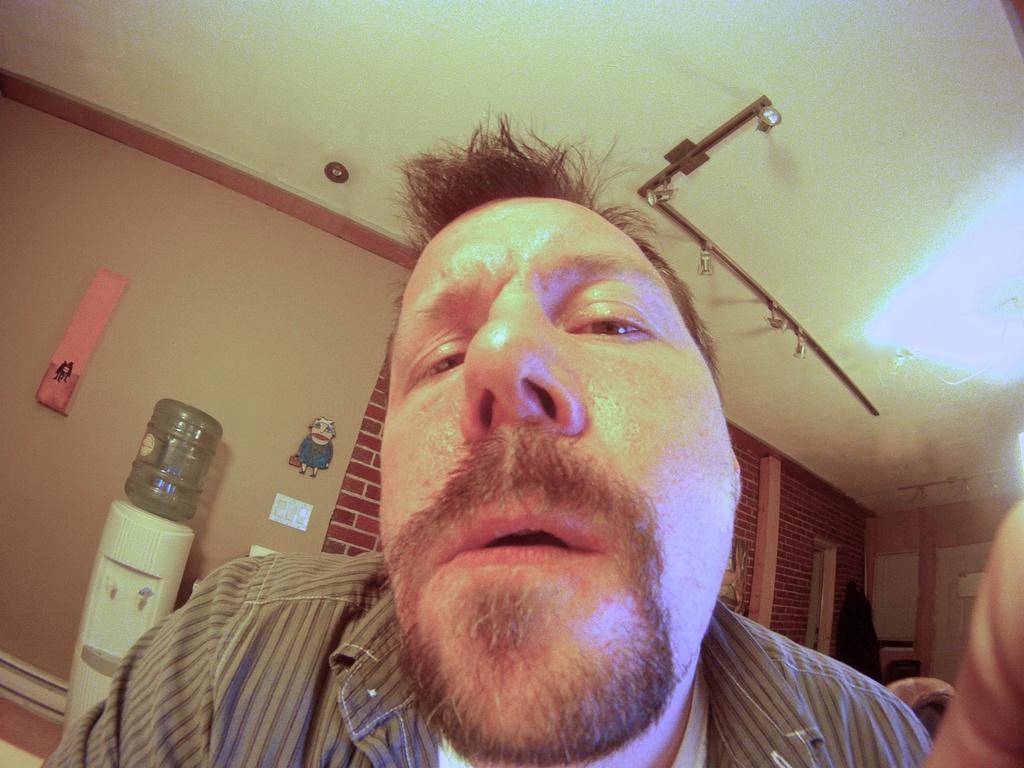Describe this image in one or two sentences. In this picture I can see a man, there is a water can on the water purifier, there are boards on the wall, there are lights and some other objects. 